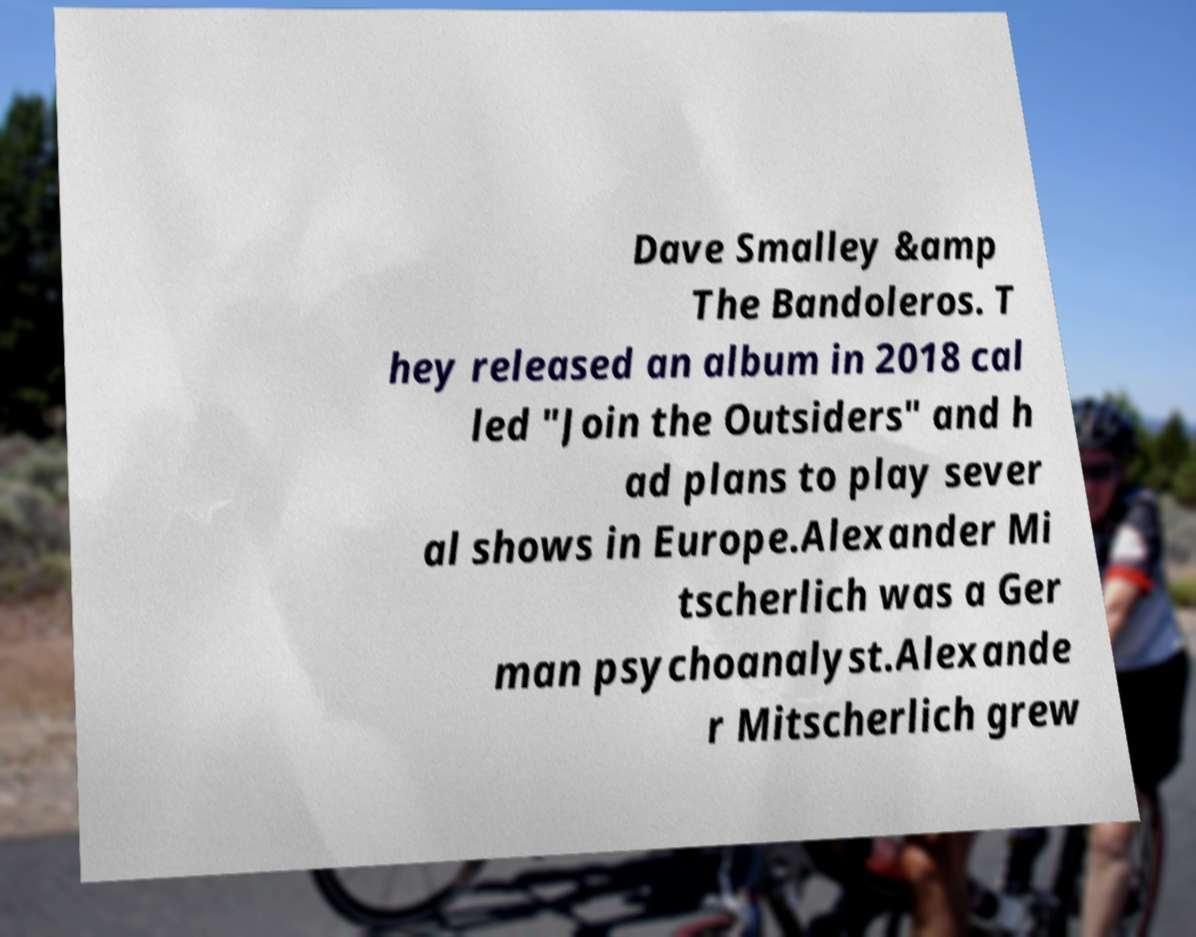Could you extract and type out the text from this image? Dave Smalley &amp The Bandoleros. T hey released an album in 2018 cal led "Join the Outsiders" and h ad plans to play sever al shows in Europe.Alexander Mi tscherlich was a Ger man psychoanalyst.Alexande r Mitscherlich grew 